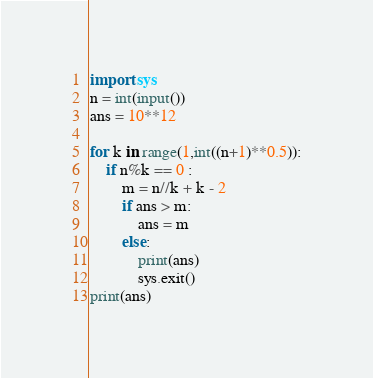<code> <loc_0><loc_0><loc_500><loc_500><_Python_>import sys
n = int(input())
ans = 10**12

for k in range(1,int((n+1)**0.5)):
    if n%k == 0 :
        m = n//k + k - 2
        if ans > m:
            ans = m
        else:
            print(ans)
            sys.exit()
print(ans)</code> 